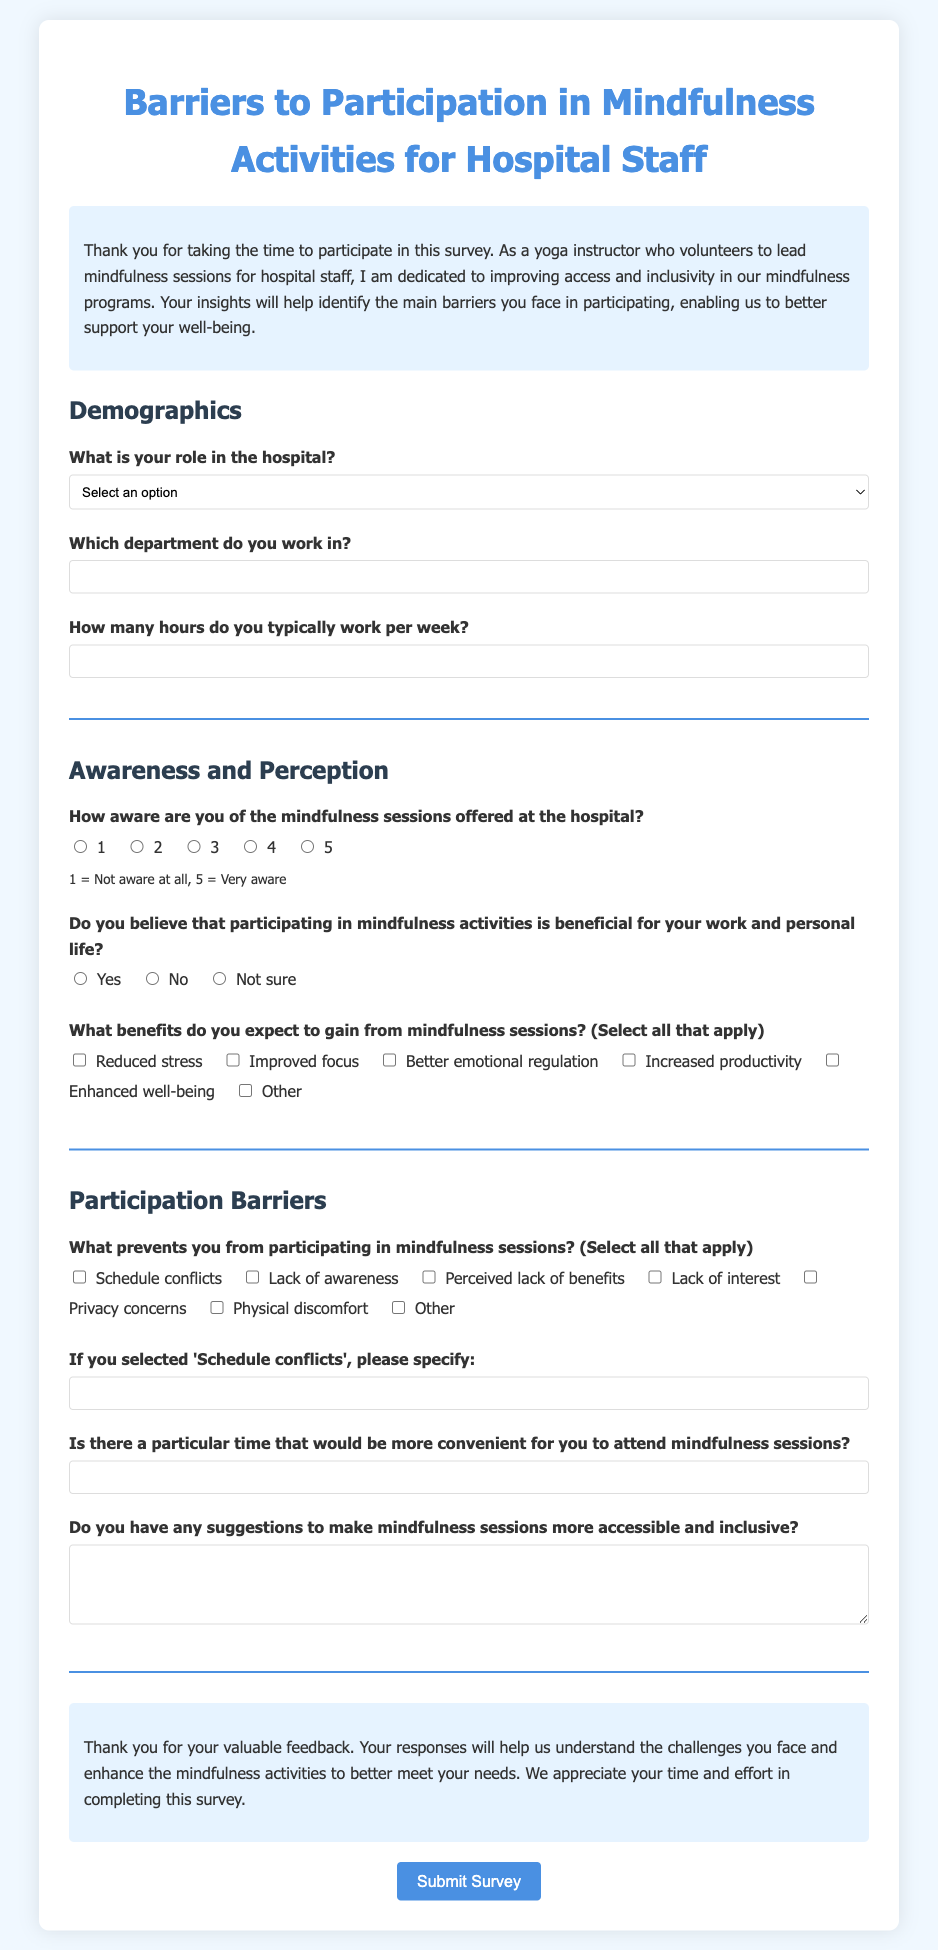What is the title of the survey? The title of the survey is presented at the top of the document, which is "Barriers to Participation in Mindfulness Activities for Hospital Staff."
Answer: Barriers to Participation in Mindfulness Activities for Hospital Staff How many sections are there in the survey? The document presents three main sections: Demographics, Awareness and Perception, and Participation Barriers.
Answer: 3 What is the minimum number of hours hospital staff can work per week according to the survey? The survey specifies that participants need to provide the number of hours they work per week, with a minimum value indicated as "0."
Answer: 0 What is one of the options for the role in the hospital? The survey includes multiple options for hospital staff roles, one being "Nurse."
Answer: Nurse What question asks about the awareness of mindfulness sessions? The survey includes a question that asks, "How aware are you of the mindfulness sessions offered at the hospital?"
Answer: How aware are you of the mindfulness sessions offered at the hospital? What label is provided for the radio buttons measuring awareness? The options for awareness are associated with a scale where "1 = Not aware at all" and "5 = Very aware" are provided as labels.
Answer: 1 = Not aware at all, 5 = Very aware What is one of the barriers participants can select for not attending mindfulness sessions? The survey allows participants to select "Lack of awareness" as one of the possible barriers to participation.
Answer: Lack of awareness How is the feedback received from the survey described? The conclusion of the survey expresses gratitude and states that the feedback received will be valuable in understanding challenges and enhancing mindfulness activities.
Answer: Valuable feedback What is the button text for submitting the survey? At the bottom of the survey form, the button used to submit the survey is labeled "Submit Survey."
Answer: Submit Survey 